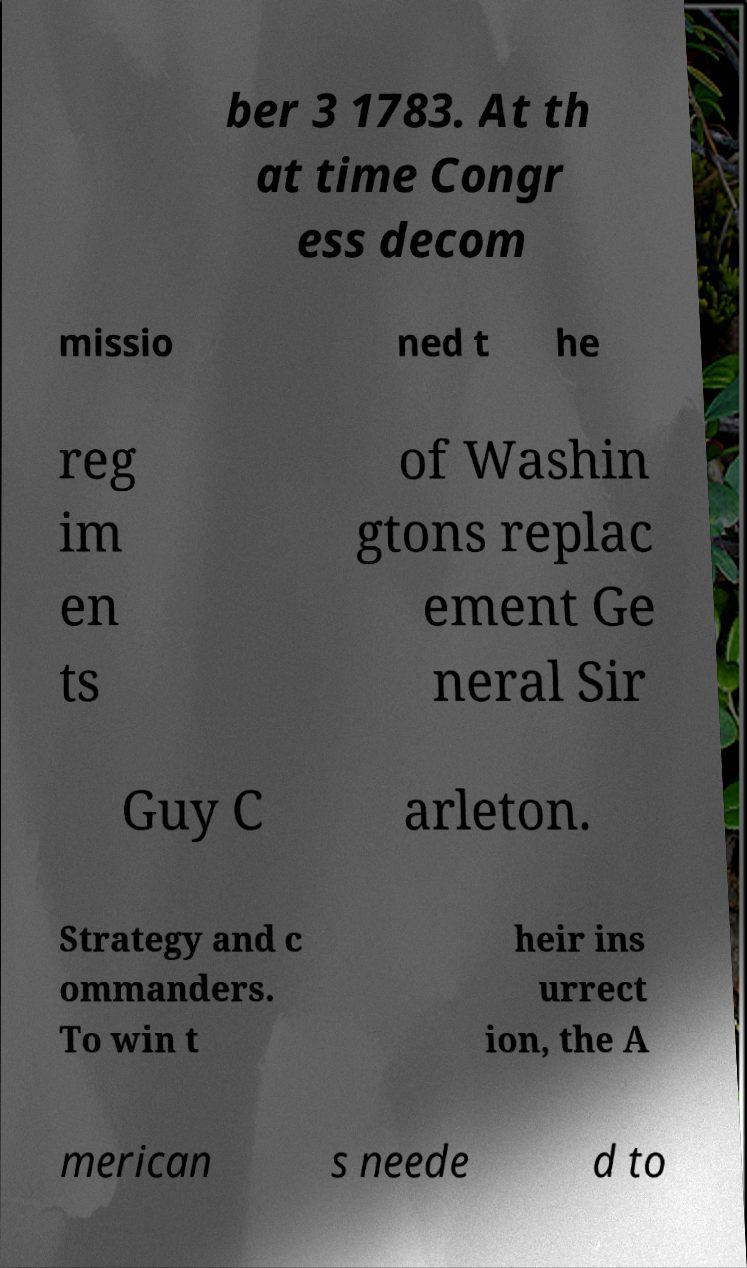Could you extract and type out the text from this image? ber 3 1783. At th at time Congr ess decom missio ned t he reg im en ts of Washin gtons replac ement Ge neral Sir Guy C arleton. Strategy and c ommanders. To win t heir ins urrect ion, the A merican s neede d to 